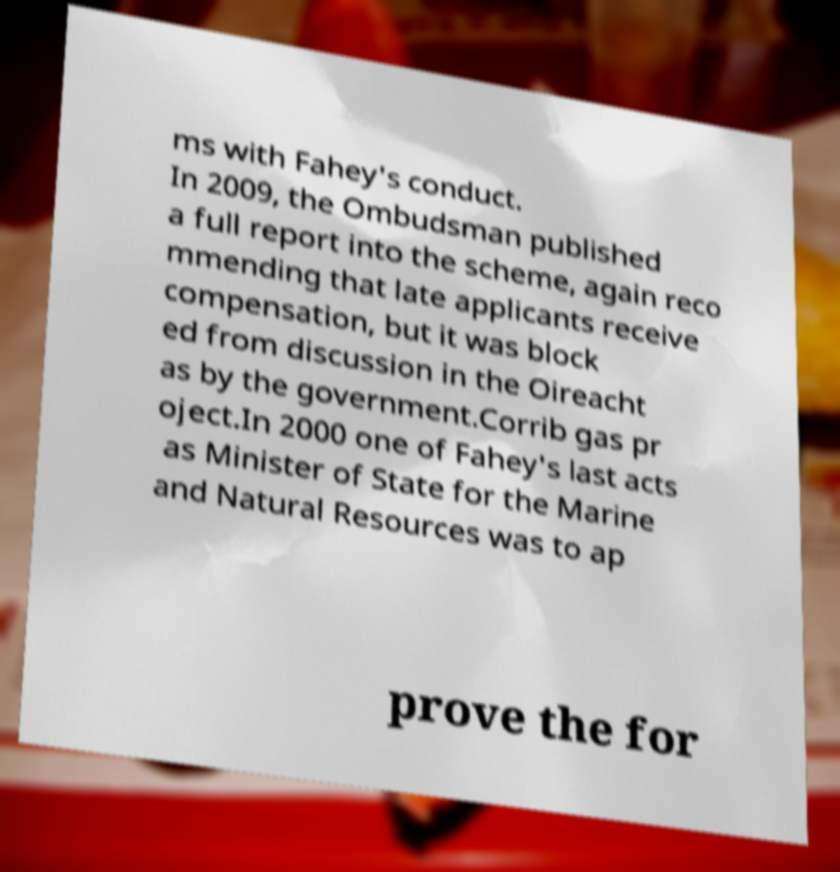Please read and relay the text visible in this image. What does it say? ms with Fahey's conduct. In 2009, the Ombudsman published a full report into the scheme, again reco mmending that late applicants receive compensation, but it was block ed from discussion in the Oireacht as by the government.Corrib gas pr oject.In 2000 one of Fahey's last acts as Minister of State for the Marine and Natural Resources was to ap prove the for 